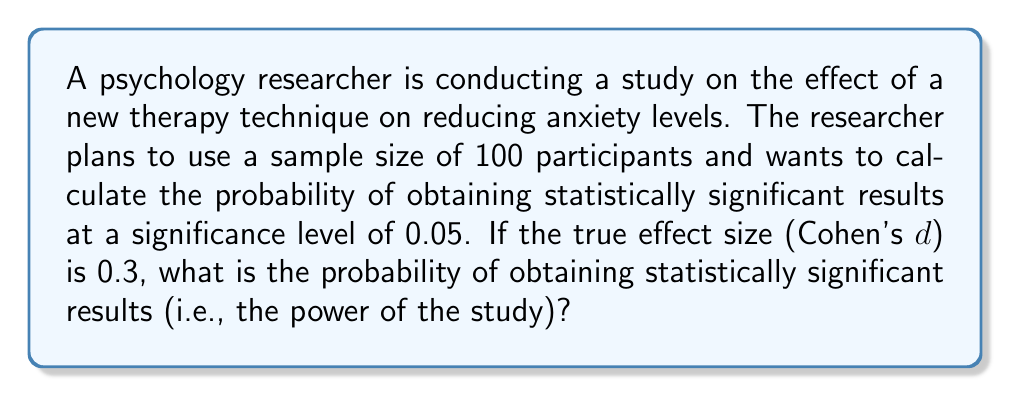Give your solution to this math problem. To solve this problem, we need to follow these steps:

1. Identify the key parameters:
   - Sample size (n) = 100
   - Significance level (α) = 0.05
   - Effect size (Cohen's d) = 0.3

2. Calculate the critical t-value for a two-tailed test with α = 0.05 and df = 98:
   The critical t-value can be found using a t-distribution table or calculator. For df = 98 and α = 0.05 (two-tailed), t_crit ≈ 1.984

3. Calculate the non-centrality parameter (δ):
   $$δ = d * \sqrt{\frac{n}{2}} = 0.3 * \sqrt{\frac{100}{2}} = 2.121$$

4. Calculate the power using the non-central t-distribution:
   Power = 1 - β, where β is the probability of a Type II error.
   We need to find the probability that the absolute value of the t-statistic is greater than t_crit, given the non-centrality parameter δ.

   $$\text{Power} = 1 - P(-t_{\text{crit}} < T < t_{\text{crit}} | δ)$$
   $$= 1 - [F_{t(98,δ)}(1.984) - F_{t(98,δ)}(-1.984)]$$

   Where F_{t(98,δ)} is the cumulative distribution function of the non-central t-distribution with 98 degrees of freedom and non-centrality parameter δ.

5. Use a statistical software or calculator to compute this probability:
   The resulting power is approximately 0.5768 or 57.68%.

This means that the probability of obtaining statistically significant results in this study, given the specified parameters, is about 57.68%.
Answer: 0.5768 or 57.68% 